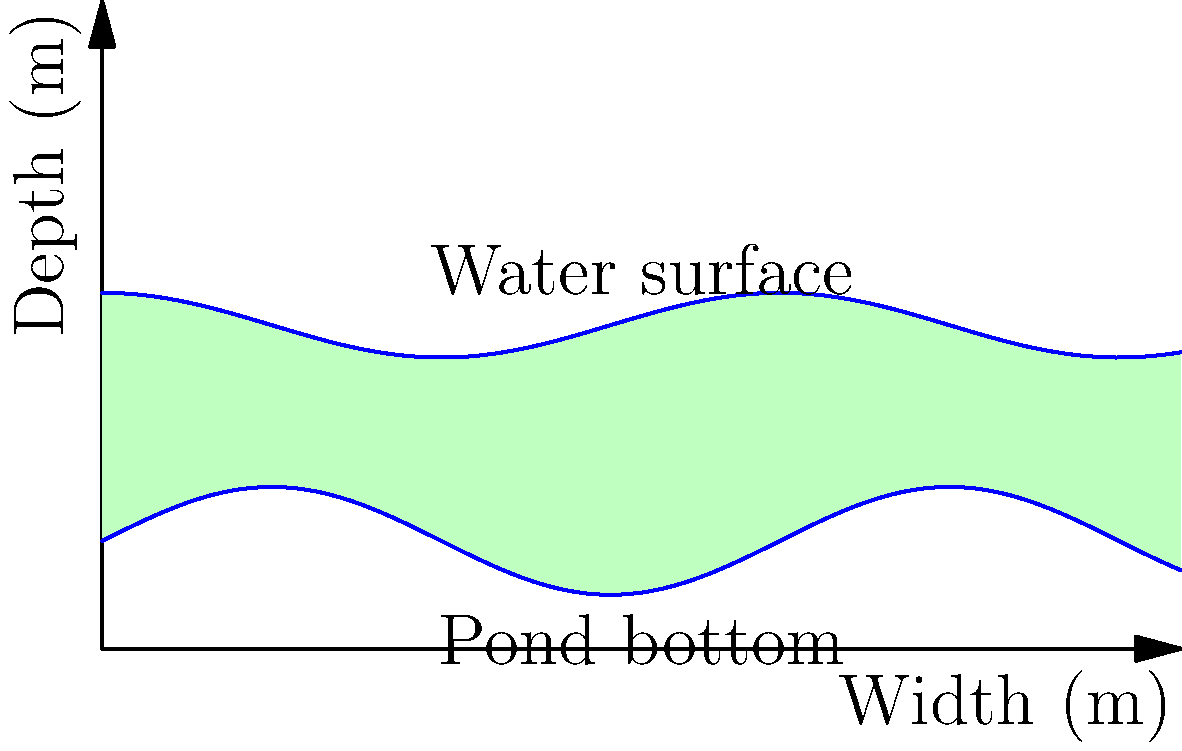A wildlife pond with an irregular shape is being planned for a nature reserve. The cross-section of the pond is shown in the diagram, where the blue lines represent the water surface and the pond bottom. The width of the pond is 10 meters. Estimate the volume of water (in cubic meters) needed to fill this pond if it has a length of 15 meters. To estimate the volume of water needed to fill the irregular-shaped wildlife pond, we'll follow these steps:

1. Observe that the pond's cross-section is irregular, with varying depths.

2. Estimate the average depth:
   - The water surface varies between about 3m and 3.3m depth.
   - The pond bottom varies between about 1m and 1.5m depth.
   - Estimated average depth: $\frac{(3 + 3.3) / 2 - (1 + 1.5) / 2}{2} \approx 1.9$ meters

3. Calculate the approximate cross-sectional area:
   - Area ≈ average depth × width
   - Area ≈ $1.9 \text{ m} \times 10 \text{ m} = 19 \text{ m}^2$

4. Calculate the volume:
   - Volume = cross-sectional area × length
   - Volume ≈ $19 \text{ m}^2 \times 15 \text{ m} = 285 \text{ m}^3$

5. Round to a reasonable precision considering the estimation:
   - Estimated volume ≈ 290 cubic meters

This method provides a reasonable estimate for the irregular-shaped pond, which is suitable for planning purposes in wildlife conservation projects.
Answer: 290 cubic meters 